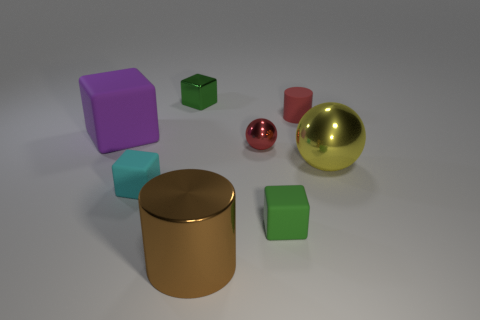Subtract all purple cylinders. How many green cubes are left? 2 Subtract all big purple blocks. How many blocks are left? 3 Subtract all purple cubes. How many cubes are left? 3 Add 1 gray metallic things. How many objects exist? 9 Subtract all cylinders. How many objects are left? 6 Subtract all red cubes. Subtract all blue cylinders. How many cubes are left? 4 Add 5 cyan blocks. How many cyan blocks exist? 6 Subtract 1 cyan cubes. How many objects are left? 7 Subtract all tiny green metal blocks. Subtract all tiny green rubber blocks. How many objects are left? 6 Add 8 large yellow metal spheres. How many large yellow metal spheres are left? 9 